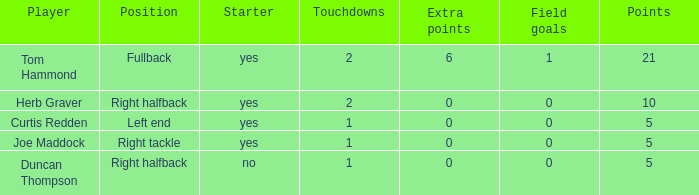Name the most extra points for right tackle 0.0. 